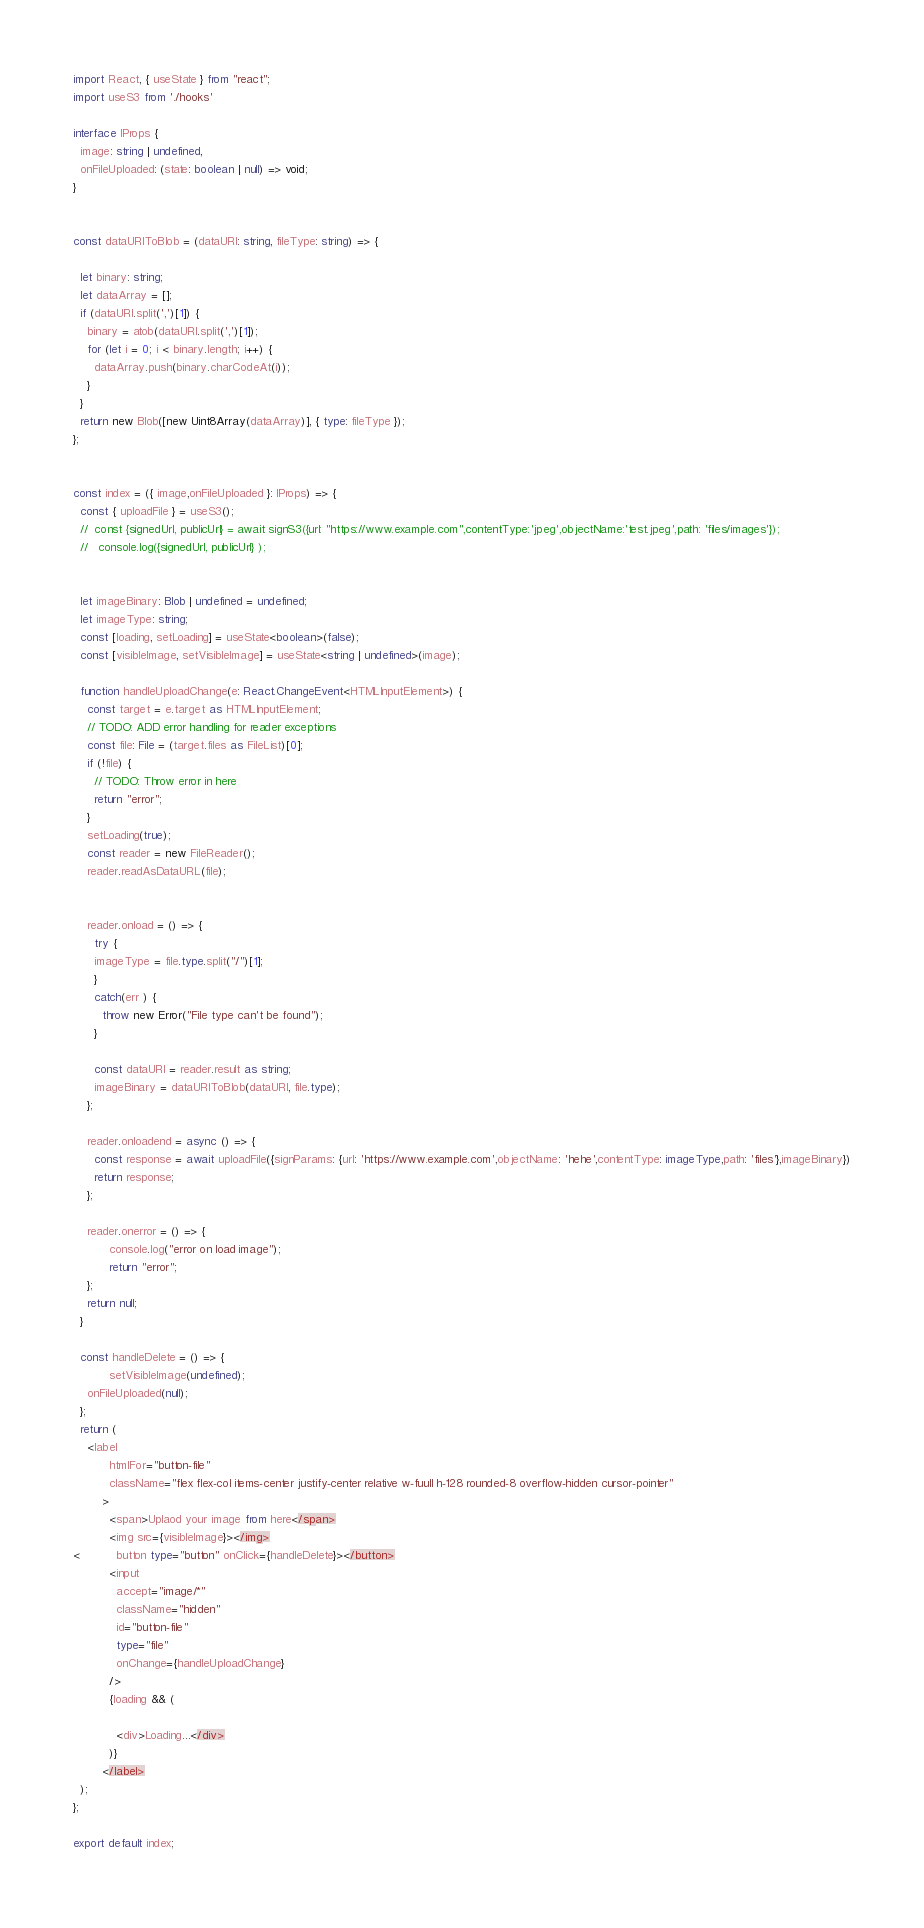<code> <loc_0><loc_0><loc_500><loc_500><_TypeScript_>import React, { useState } from "react";
import useS3 from './hooks'

interface IProps {
  image: string | undefined,
  onFileUploaded: (state: boolean | null) => void;
}


const dataURIToBlob = (dataURI: string, fileType: string) => {
  
  let binary: string;
  let dataArray = [];
  if (dataURI.split(',')[1]) {
    binary = atob(dataURI.split(',')[1]);
    for (let i = 0; i < binary.length; i++) {
      dataArray.push(binary.charCodeAt(i));
    }
  }
  return new Blob([new Uint8Array(dataArray)], { type: fileType });
};


const index = ({ image,onFileUploaded }: IProps) => {
  const { uploadFile } = useS3();
  //  const {signedUrl, publicUrl} = await signS3({url: "https://www.example.com",contentType:'jpeg',objectName:'test.jpeg',path: 'files/images'});
  //   console.log({signedUrl, publicUrl} );


  let imageBinary: Blob | undefined = undefined;
  let imageType: string;
  const [loading, setLoading] = useState<boolean>(false);
  const [visibleImage, setVisibleImage] = useState<string | undefined>(image);

  function handleUploadChange(e: React.ChangeEvent<HTMLInputElement>) {
    const target = e.target as HTMLInputElement;
    // TODO: ADD error handling for reader exceptions
    const file: File = (target.files as FileList)[0];
    if (!file) {
      // TODO: Throw error in here
      return "error";
    }
    setLoading(true);
    const reader = new FileReader();
    reader.readAsDataURL(file);


    reader.onload = () => {
      try {
      imageType = file.type.split("/")[1];
      }
      catch(err ) {
        throw new Error("File type can't be found");
      }
      
      const dataURI = reader.result as string;
      imageBinary = dataURIToBlob(dataURI, file.type);
    };

    reader.onloadend = async () => {
      const response = await uploadFile({signParams: {url: 'https://www.example.com',objectName: 'hehe',contentType: imageType,path: 'files'},imageBinary})
      return response;
    };

    reader.onerror = () => {
          console.log("error on load image");
          return "error";
    };
    return null;
  }

  const handleDelete = () => {
          setVisibleImage(undefined);
    onFileUploaded(null);
  };
  return (
    <label
          htmlFor="button-file"
          className="flex flex-col items-center justify-center relative w-fuull h-128 rounded-8 overflow-hidden cursor-pointer"
        >
          <span>Uplaod your image from here</span>
          <img src={visibleImage}></img>
<          button type="button" onClick={handleDelete}></button>
          <input
            accept="image/*"
            className="hidden"
            id="button-file"
            type="file"
            onChange={handleUploadChange}
          />
          {loading && (

            <div>Loading...</div>
          )}
        </label>
  );
};

export default index;
</code> 